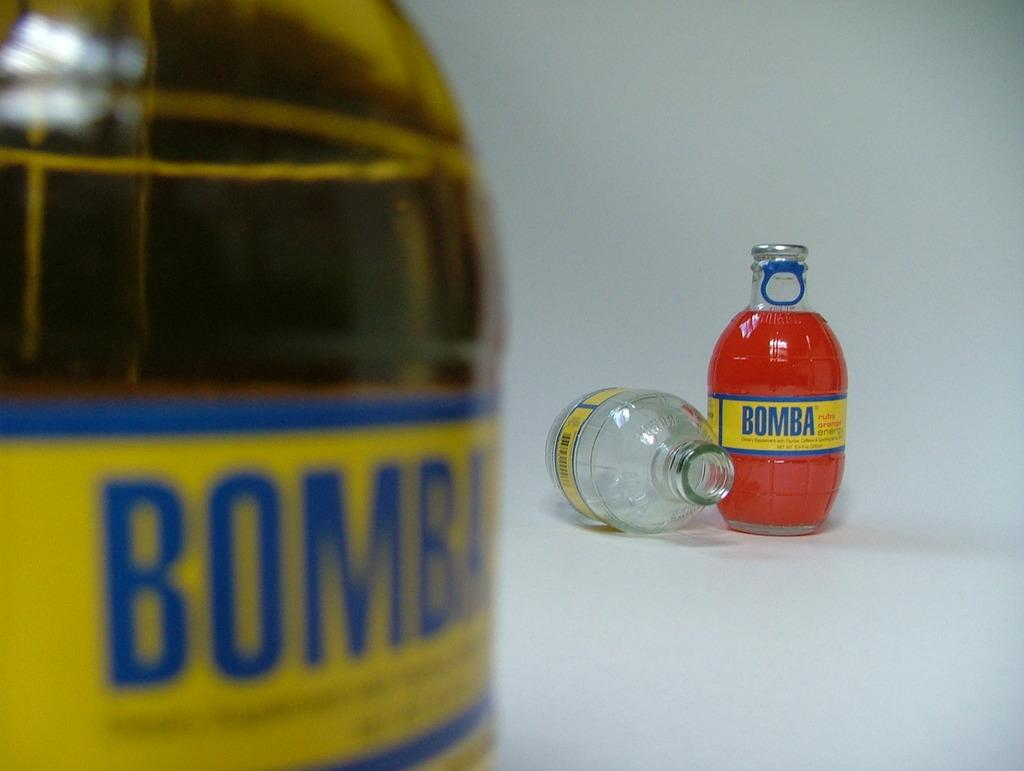<image>
Provide a brief description of the given image. Two full bottles of Bomba are shown with an empty bottle. 